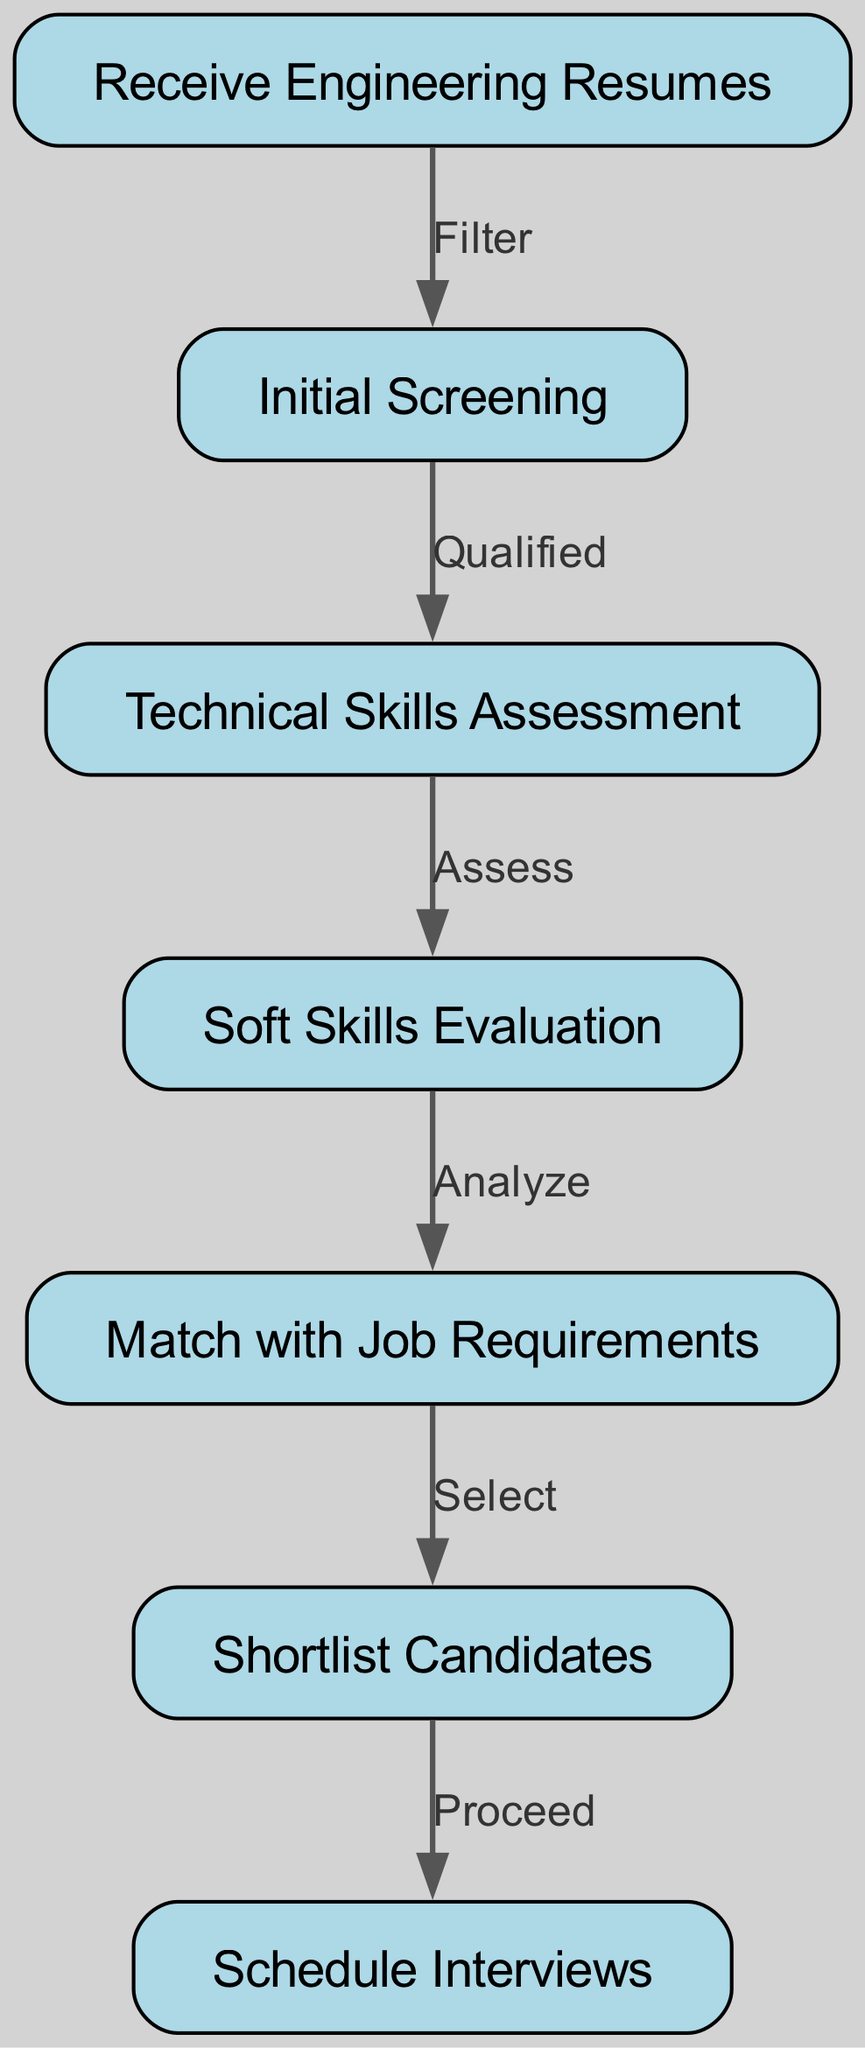What is the first step in the process? The first step in the process is indicated by the first node in the diagram, which is "Receive Engineering Resumes."
Answer: Receive Engineering Resumes How many nodes are present in the diagram? By counting the entries in the "nodes" section of the data, there are a total of 7 nodes representing different stages of the recruitment process.
Answer: 7 What is the label on the edge from "Initial Screening" to "Technical Skills Assessment"? The label on the edge indicates the relationship or action taken between these two nodes, which is "Qualified."
Answer: Qualified Which node follows "Soft Skills Evaluation"? The node that follows "Soft Skills Evaluation" in the sequence of the process flow is "Match with Job Requirements."
Answer: Match with Job Requirements What action is taken after shortlisting candidates? After shortlisting candidates, the action taken is to "Schedule Interviews," as shown by the edge connecting these two nodes.
Answer: Schedule Interviews What is the total number of edges in the diagram? The total number of edges is determined by counting the connections in the "edges" section, which amounts to 6 edges representing the flow between nodes.
Answer: 6 Which step involves examining both technical and soft skills? The steps involving examination of skills are "Technical Skills Assessment" and "Soft Skills Evaluation," but the specific question asks for the second step, which is "Soft Skills Evaluation."
Answer: Soft Skills Evaluation How are candidates selected based on their skills? Candidates are selected based on the analysis conducted in the "Match with Job Requirements," which leads to the node "Shortlist Candidates."
Answer: Match with Job Requirements What precedes the "Schedule Interviews" step? The step that precedes "Schedule Interviews" is "Shortlist Candidates," indicating that candidates must be shortlisted before interviews can be scheduled.
Answer: Shortlist Candidates 